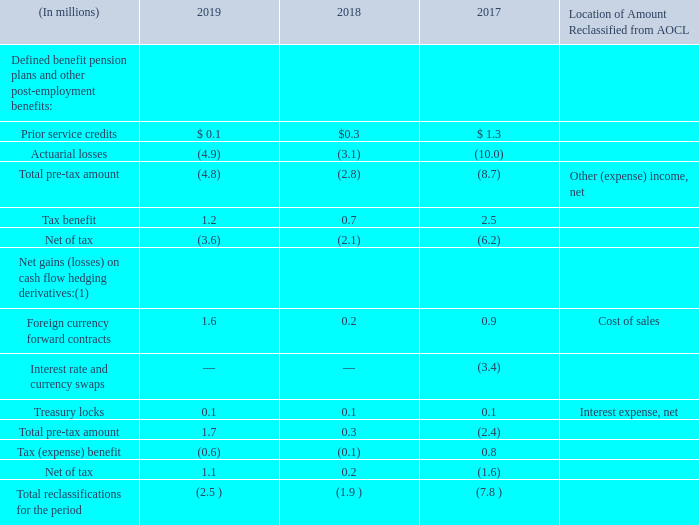The following table provides detail of amounts reclassified from AOCL:
(1) These accumulated other comprehensive components are included in our derivative and hedging activities. See Note 15, “Derivatives and Hedging Activities,” of the Notes to Consolidated Financial Statements for additional details.
What does the table represent? Detail of amounts reclassified from aocl. What years are included in the table? 2019, 2018, 2017. What is the Net of tax for 2018?
Answer scale should be: million. 0.2. What is the total Prior service credits for the 3 years?
Answer scale should be: million. 0.1+0.3+1.3
Answer: 1.7. What is the average Total reclassifications for the period for the 3 years?
Answer scale should be: million. -(2.5+1.9+7.8)/3
Answer: -4.07. For Treasury locks in 2019, What is the Net of tax expressed as a percentage of Total pre-tax amount?
Answer scale should be: percent. 1.1/1.7
Answer: 64.71. 